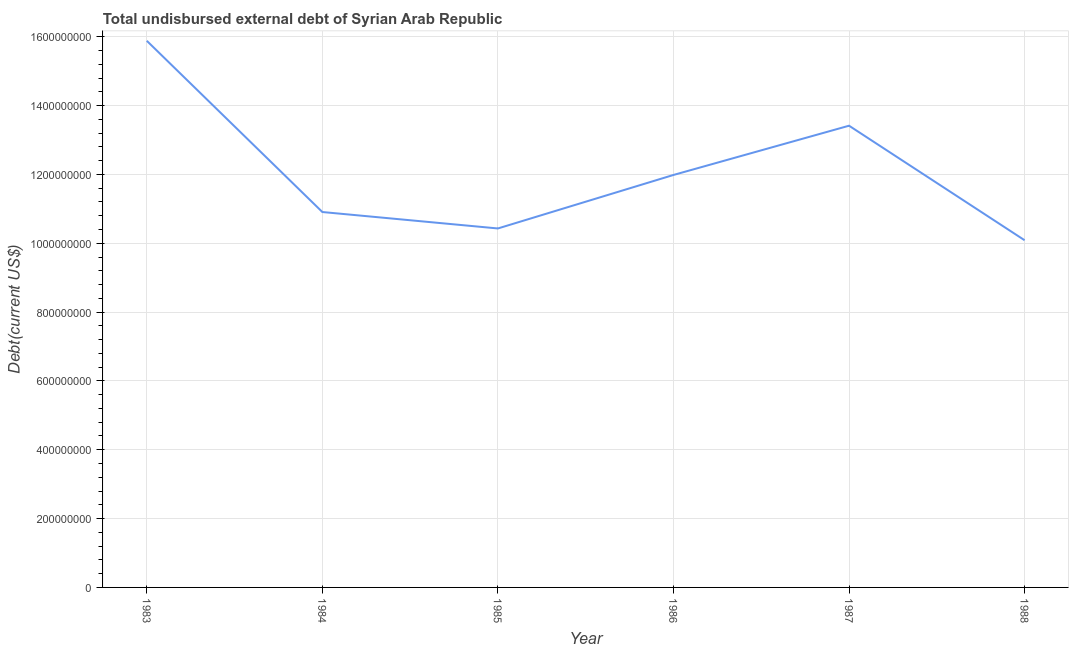What is the total debt in 1988?
Your answer should be very brief. 1.01e+09. Across all years, what is the maximum total debt?
Your answer should be compact. 1.59e+09. Across all years, what is the minimum total debt?
Give a very brief answer. 1.01e+09. What is the sum of the total debt?
Your answer should be very brief. 7.27e+09. What is the difference between the total debt in 1983 and 1987?
Provide a short and direct response. 2.47e+08. What is the average total debt per year?
Ensure brevity in your answer.  1.21e+09. What is the median total debt?
Keep it short and to the point. 1.14e+09. In how many years, is the total debt greater than 1440000000 US$?
Your response must be concise. 1. Do a majority of the years between 1987 and 1983 (inclusive) have total debt greater than 160000000 US$?
Your answer should be compact. Yes. What is the ratio of the total debt in 1983 to that in 1984?
Your response must be concise. 1.46. What is the difference between the highest and the second highest total debt?
Give a very brief answer. 2.47e+08. What is the difference between the highest and the lowest total debt?
Ensure brevity in your answer.  5.79e+08. In how many years, is the total debt greater than the average total debt taken over all years?
Provide a succinct answer. 2. How many lines are there?
Offer a very short reply. 1. Are the values on the major ticks of Y-axis written in scientific E-notation?
Provide a succinct answer. No. Does the graph contain any zero values?
Your answer should be compact. No. Does the graph contain grids?
Offer a very short reply. Yes. What is the title of the graph?
Ensure brevity in your answer.  Total undisbursed external debt of Syrian Arab Republic. What is the label or title of the X-axis?
Keep it short and to the point. Year. What is the label or title of the Y-axis?
Your response must be concise. Debt(current US$). What is the Debt(current US$) in 1983?
Make the answer very short. 1.59e+09. What is the Debt(current US$) of 1984?
Keep it short and to the point. 1.09e+09. What is the Debt(current US$) in 1985?
Provide a short and direct response. 1.04e+09. What is the Debt(current US$) of 1986?
Make the answer very short. 1.20e+09. What is the Debt(current US$) of 1987?
Your response must be concise. 1.34e+09. What is the Debt(current US$) of 1988?
Keep it short and to the point. 1.01e+09. What is the difference between the Debt(current US$) in 1983 and 1984?
Your answer should be compact. 4.97e+08. What is the difference between the Debt(current US$) in 1983 and 1985?
Make the answer very short. 5.45e+08. What is the difference between the Debt(current US$) in 1983 and 1986?
Provide a succinct answer. 3.90e+08. What is the difference between the Debt(current US$) in 1983 and 1987?
Your response must be concise. 2.47e+08. What is the difference between the Debt(current US$) in 1983 and 1988?
Offer a very short reply. 5.79e+08. What is the difference between the Debt(current US$) in 1984 and 1985?
Offer a terse response. 4.78e+07. What is the difference between the Debt(current US$) in 1984 and 1986?
Your response must be concise. -1.08e+08. What is the difference between the Debt(current US$) in 1984 and 1987?
Provide a short and direct response. -2.51e+08. What is the difference between the Debt(current US$) in 1984 and 1988?
Your response must be concise. 8.20e+07. What is the difference between the Debt(current US$) in 1985 and 1986?
Keep it short and to the point. -1.55e+08. What is the difference between the Debt(current US$) in 1985 and 1987?
Your response must be concise. -2.99e+08. What is the difference between the Debt(current US$) in 1985 and 1988?
Provide a short and direct response. 3.42e+07. What is the difference between the Debt(current US$) in 1986 and 1987?
Offer a very short reply. -1.43e+08. What is the difference between the Debt(current US$) in 1986 and 1988?
Provide a succinct answer. 1.90e+08. What is the difference between the Debt(current US$) in 1987 and 1988?
Offer a terse response. 3.33e+08. What is the ratio of the Debt(current US$) in 1983 to that in 1984?
Offer a terse response. 1.46. What is the ratio of the Debt(current US$) in 1983 to that in 1985?
Provide a short and direct response. 1.52. What is the ratio of the Debt(current US$) in 1983 to that in 1986?
Your answer should be compact. 1.32. What is the ratio of the Debt(current US$) in 1983 to that in 1987?
Provide a succinct answer. 1.18. What is the ratio of the Debt(current US$) in 1983 to that in 1988?
Provide a succinct answer. 1.57. What is the ratio of the Debt(current US$) in 1984 to that in 1985?
Your answer should be compact. 1.05. What is the ratio of the Debt(current US$) in 1984 to that in 1986?
Provide a succinct answer. 0.91. What is the ratio of the Debt(current US$) in 1984 to that in 1987?
Give a very brief answer. 0.81. What is the ratio of the Debt(current US$) in 1984 to that in 1988?
Provide a succinct answer. 1.08. What is the ratio of the Debt(current US$) in 1985 to that in 1986?
Give a very brief answer. 0.87. What is the ratio of the Debt(current US$) in 1985 to that in 1987?
Provide a succinct answer. 0.78. What is the ratio of the Debt(current US$) in 1985 to that in 1988?
Give a very brief answer. 1.03. What is the ratio of the Debt(current US$) in 1986 to that in 1987?
Ensure brevity in your answer.  0.89. What is the ratio of the Debt(current US$) in 1986 to that in 1988?
Your answer should be compact. 1.19. What is the ratio of the Debt(current US$) in 1987 to that in 1988?
Your answer should be very brief. 1.33. 